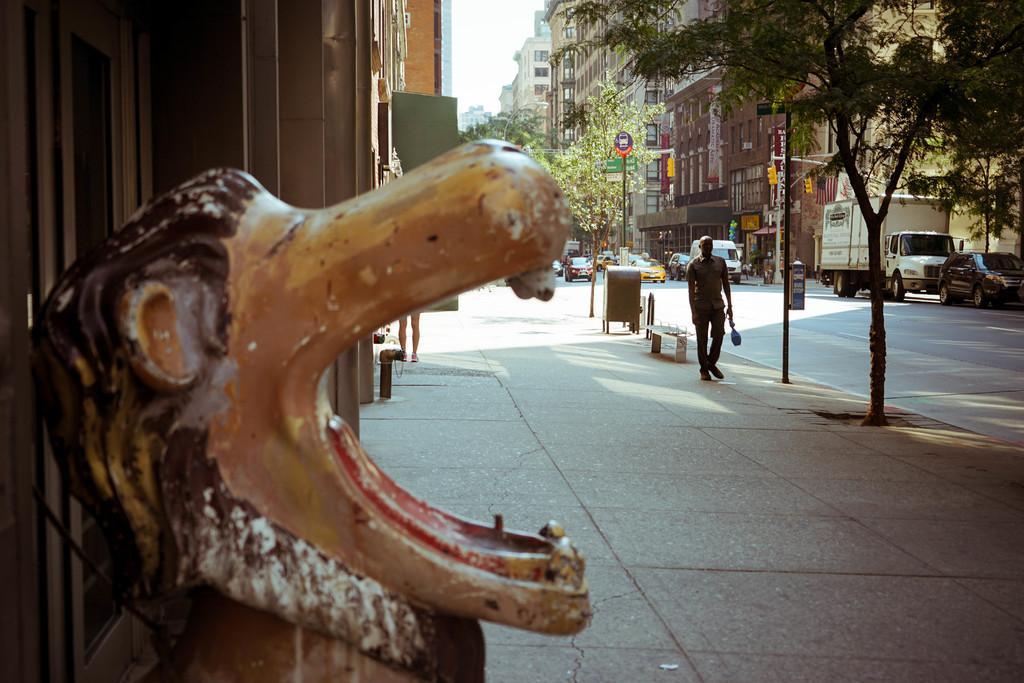Please provide a concise description of this image. This image is taken outdoors. At the bottom of the image there is a sidewalk. On the left side of the image there are a few buildings with walls and there is a statue of a lion. In the middle of the image there are a few trees, poles and street lights, a few cars are moving on the road and a man is walking on the sidewalk. There is an empty bench. At the top right of the image there are few buildings with walls, windows and roofs and a truck is moving on the road. There are few trees and there is a road. 